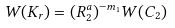Convert formula to latex. <formula><loc_0><loc_0><loc_500><loc_500>W ( K _ { r } ) = ( R _ { 2 } ^ { a } ) ^ { - m _ { 1 } } W ( C _ { 2 } )</formula> 